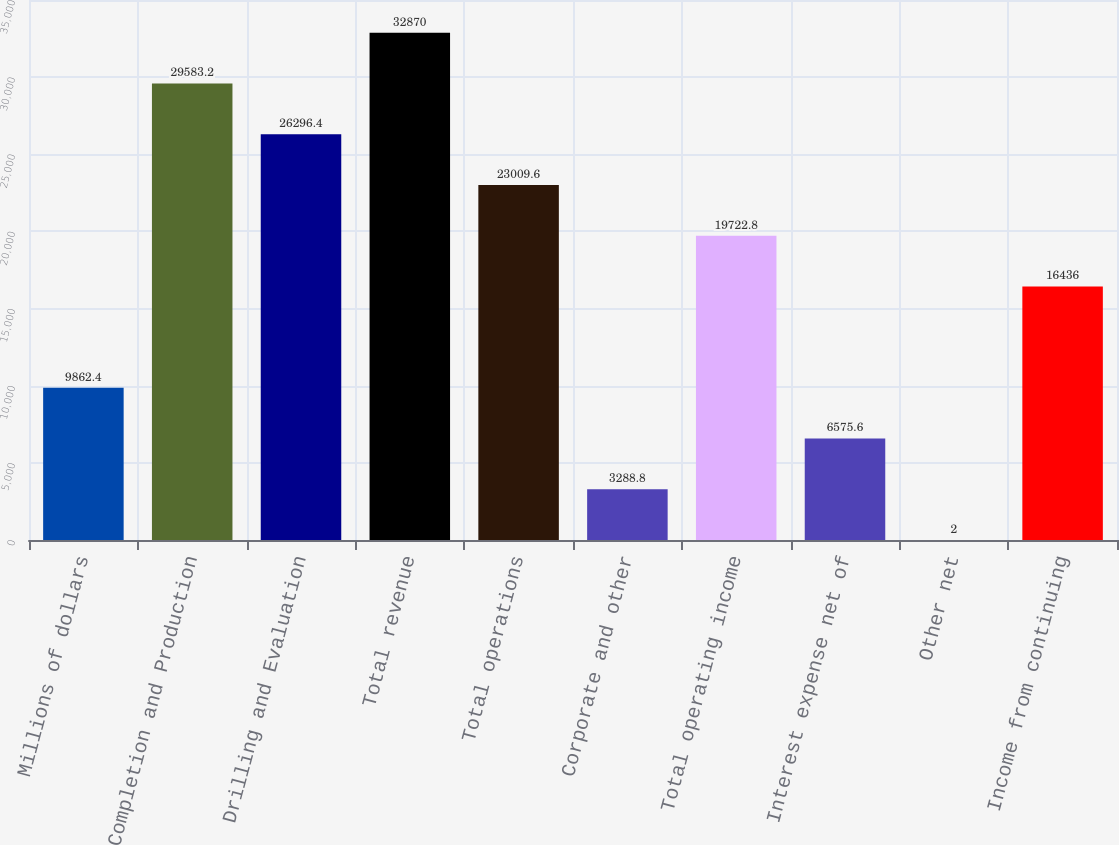<chart> <loc_0><loc_0><loc_500><loc_500><bar_chart><fcel>Millions of dollars<fcel>Completion and Production<fcel>Drilling and Evaluation<fcel>Total revenue<fcel>Total operations<fcel>Corporate and other<fcel>Total operating income<fcel>Interest expense net of<fcel>Other net<fcel>Income from continuing<nl><fcel>9862.4<fcel>29583.2<fcel>26296.4<fcel>32870<fcel>23009.6<fcel>3288.8<fcel>19722.8<fcel>6575.6<fcel>2<fcel>16436<nl></chart> 